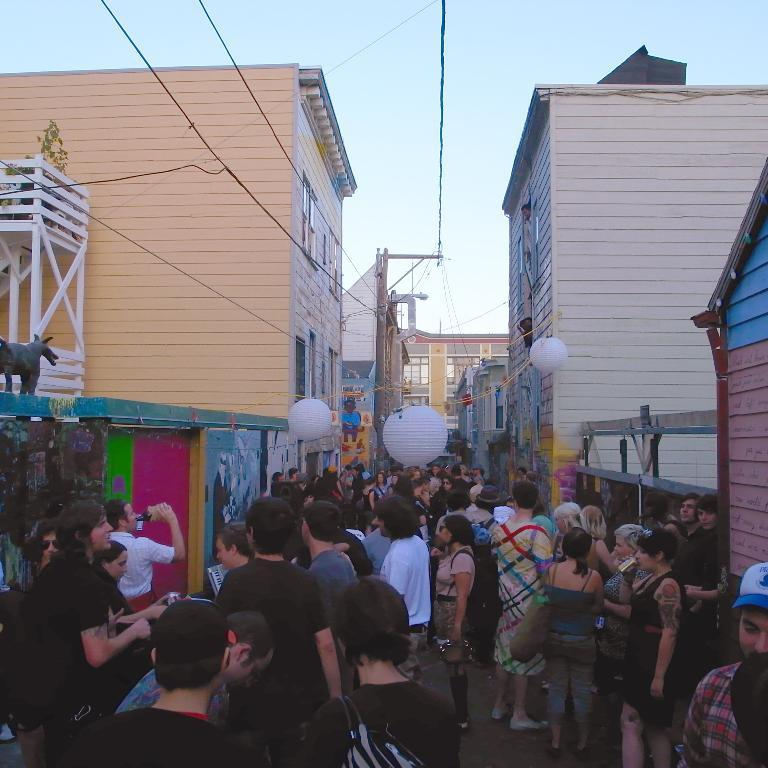What is happening on the road in the image? There are people standing on the road in the image. What can be seen on both sides of the road? Buildings are present on both sides of the road. What structures are visible at the top of the image? Electricity poles are visible at the top of the image. Where are the cherries located in the image? There are no cherries present in the image. What type of shoes are the people wearing in the image? The image does not show the people's shoes, so it cannot be determined from the image. 